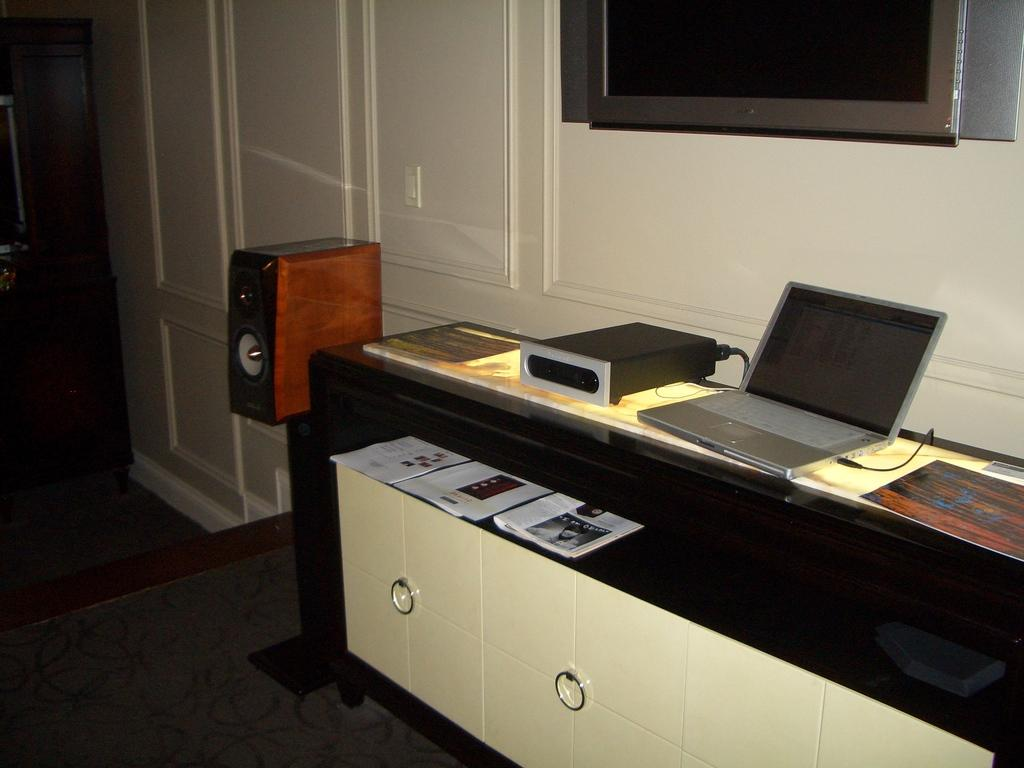What type of furniture can be seen in the image? There is a table in the image. What items are related to work or study in the image? Papers, a laptop, and devices are present in the image. What type of storage is visible in the image? There are cupboards in the image. Can you describe the cable in the image? There is a cable in the image, but its purpose is not specified. What is visible on the floor in the image? The floor is visible in the image. What can be seen in the background of the image? There is a wall and a television in the background of the image. What type of drug can be seen on the seashore in the image? There is no seashore or drug present in the image. How many minutes does it take for the minute hand to move in the image? There is no clock or time-related object present in the image. 